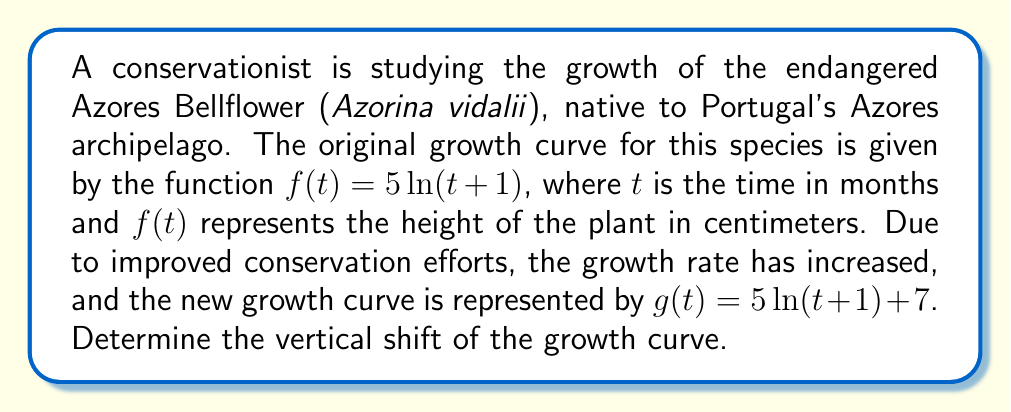Teach me how to tackle this problem. To determine the vertical shift of the growth curve, we need to compare the original function $f(t)$ with the new function $g(t)$:

1) Original function: $f(t) = 5\ln(t+1)$
2) New function: $g(t) = 5\ln(t+1) + 7$

The vertical shift of a function is represented by the constant term added to or subtracted from the original function. In this case:

3) $g(t) = f(t) + 7$

The new function $g(t)$ is obtained by adding 7 to the original function $f(t)$ for all values of $t$. This means that the graph of $g(t)$ is shifted 7 units upward compared to the graph of $f(t)$.

Therefore, the vertical shift of the growth curve is 7 units upward.
Answer: 7 units upward 